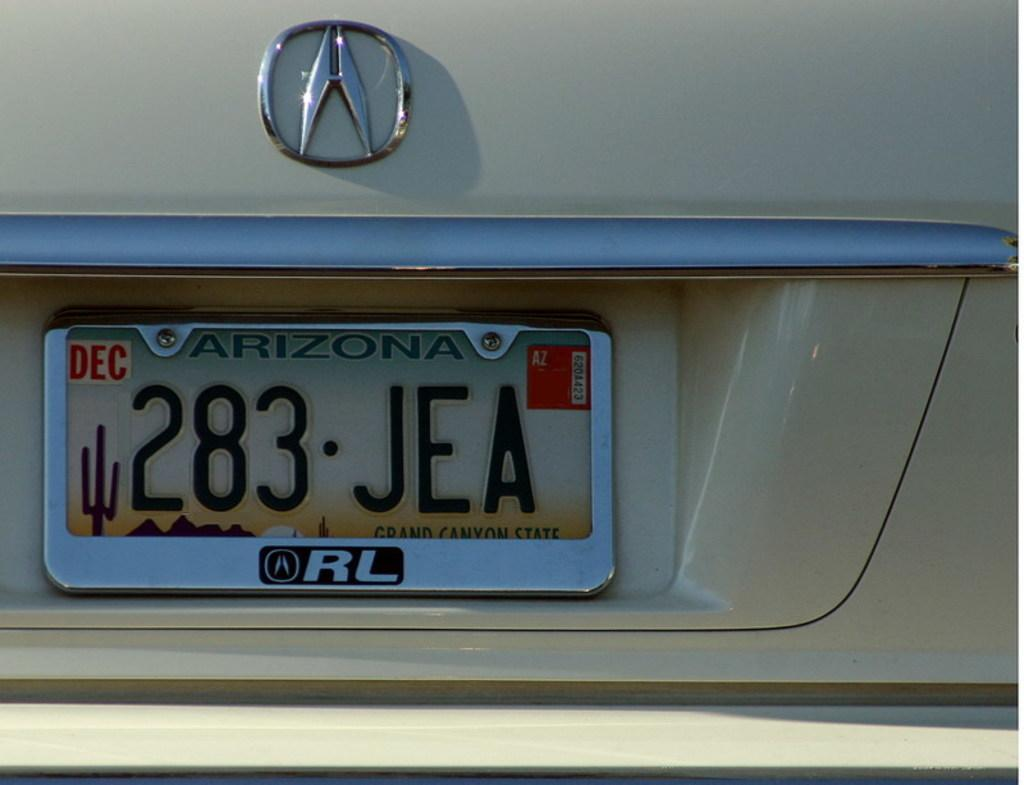<image>
Share a concise interpretation of the image provided. An Arizona license plate tag with a silver tag bracket around it that reads RL. 